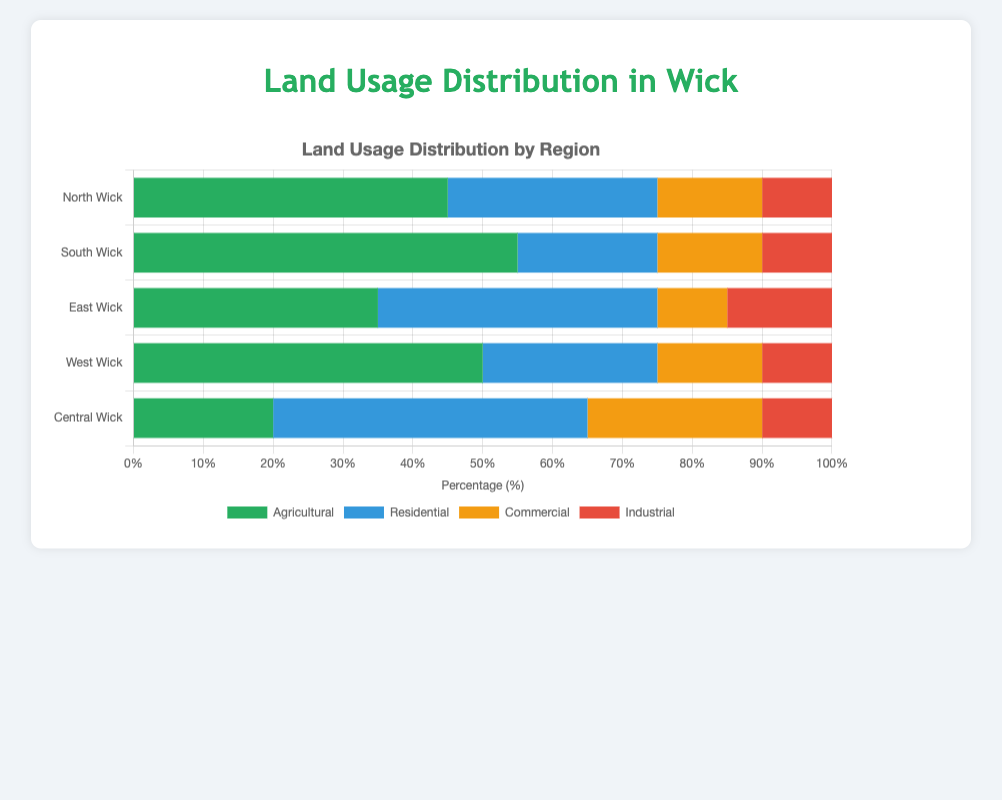Which region has the highest percentage of agricultural land? Look at the length of the green bars corresponding to Agricultural land usage across all regions. The longest green bar belongs to South Wick.
Answer: South Wick Which region has the least residential land usage? Compare the length of the blue bars corresponding to Residential land usage in all regions. The shortest blue bar is in South Wick.
Answer: South Wick What is the total commercial land usage percentage in East Wick and Central Wick combined? Add the percentages of Commercial land usage in East Wick and Central Wick: 10% + 25% = 35%.
Answer: 35% How does the percentage of agricultural land in North Wick compare to that in West Wick? Compare the lengths of the green bars for Agricultural land in North Wick and West Wick. Both are approximately the same length, indicating they are equal.
Answer: Equal What is the difference in residential land usage between East Wick and West Wick? Subtract the percentage of Residential land in West Wick (25%) from that in East Wick (40%): 40% - 25% = 15%.
Answer: 15% Which region has the highest combined percentage of residential and industrial land usage? Add the percentages of Residential and Industrial land usage for each region and compare: North Wick (30% + 10% = 40%), South Wick (20% + 10% = 30%), East Wick (40% + 15% = 55%), West Wick (25% + 10% = 35%), Central Wick (45% + 10% = 55%). East Wick and Central Wick both have the highest combined percentage of 55%.
Answer: East Wick and Central Wick How does the industrial land usage in South Wick compare to that in the other regions? Look at the length of the red bars corresponding to Industrial land usage in all regions. South Wick has the same length (10%) of Industrial land as North Wick, West Wick, and Central Wick, and less than East Wick (15%).
Answer: Same as North Wick, West Wick, Central Wick; less than East Wick Which region has the second highest percentage of agricultural land usage? Ignore South Wick (highest at 55%). Compare the green bars for the rest of the regions: North Wick (45%), East Wick (35%), West Wick (50%), Central Wick (20%). The second highest is West Wick with 50%.
Answer: West Wick What is the average percentage of commercial land usage across all regions? Add the percentages for Commercial land usage from all regions and then divide by the number of regions: (15% + 15% + 10% + 15% + 25%) / 5 = 80% / 5 = 16%.
Answer: 16% 